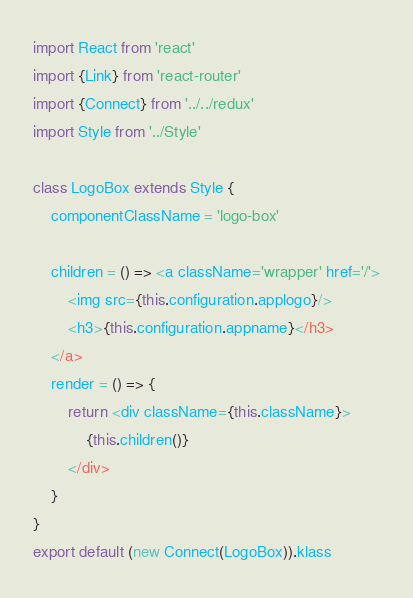Convert code to text. <code><loc_0><loc_0><loc_500><loc_500><_JavaScript_>import React from 'react'
import {Link} from 'react-router'
import {Connect} from '../../redux'
import Style from '../Style'

class LogoBox extends Style {
    componentClassName = 'logo-box'

    children = () => <a className='wrapper' href='/'>
        <img src={this.configuration.applogo}/>
        <h3>{this.configuration.appname}</h3>
    </a>
    render = () => {
        return <div className={this.className}>
            {this.children()}
        </div>
    }
}
export default (new Connect(LogoBox)).klass
</code> 